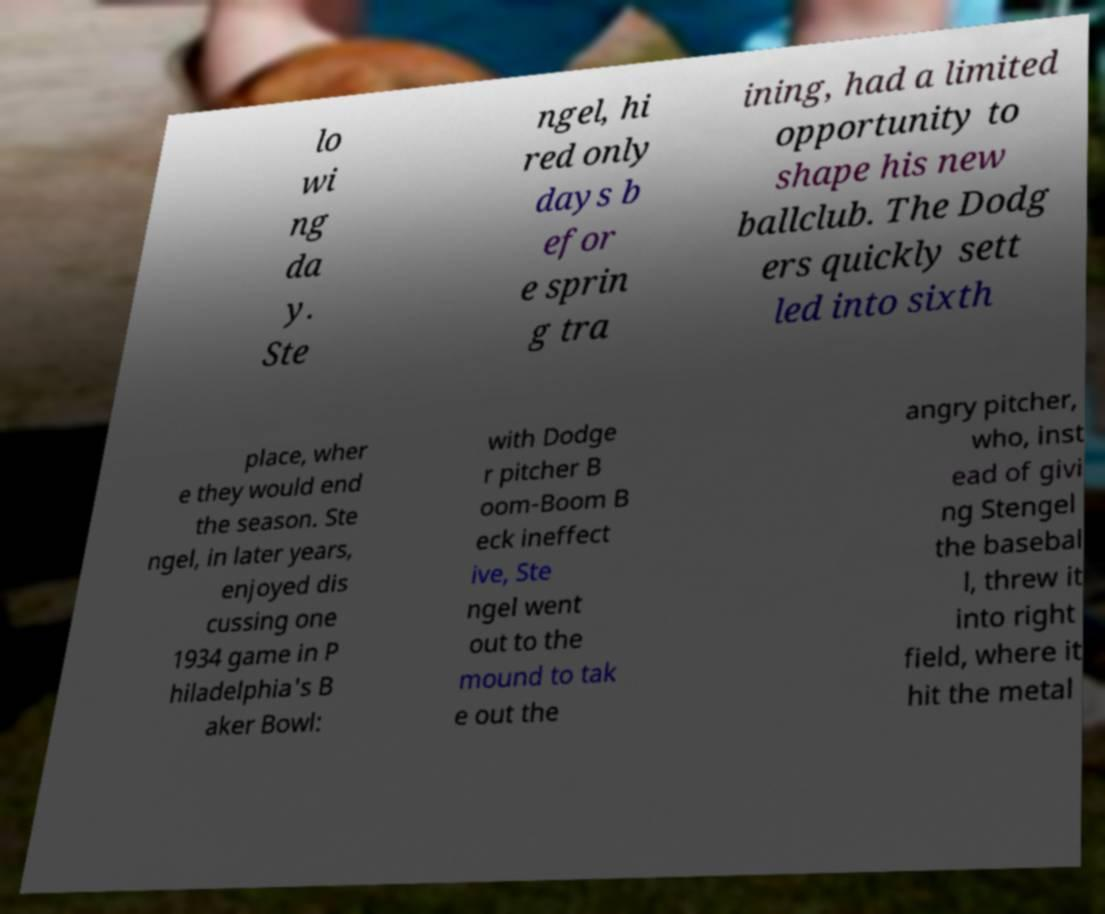Could you extract and type out the text from this image? lo wi ng da y. Ste ngel, hi red only days b efor e sprin g tra ining, had a limited opportunity to shape his new ballclub. The Dodg ers quickly sett led into sixth place, wher e they would end the season. Ste ngel, in later years, enjoyed dis cussing one 1934 game in P hiladelphia's B aker Bowl: with Dodge r pitcher B oom-Boom B eck ineffect ive, Ste ngel went out to the mound to tak e out the angry pitcher, who, inst ead of givi ng Stengel the basebal l, threw it into right field, where it hit the metal 